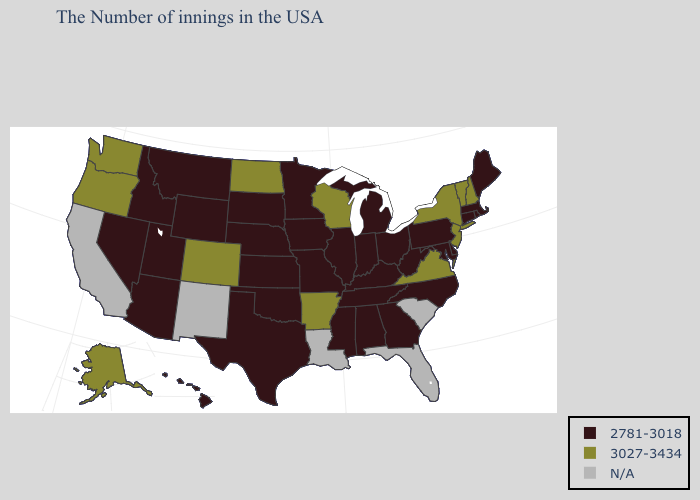What is the value of Hawaii?
Give a very brief answer. 2781-3018. Name the states that have a value in the range 3027-3434?
Write a very short answer. New Hampshire, Vermont, New York, New Jersey, Virginia, Wisconsin, Arkansas, North Dakota, Colorado, Washington, Oregon, Alaska. What is the highest value in the MidWest ?
Concise answer only. 3027-3434. Among the states that border Nebraska , does South Dakota have the highest value?
Short answer required. No. Name the states that have a value in the range N/A?
Quick response, please. South Carolina, Florida, Louisiana, New Mexico, California. Name the states that have a value in the range N/A?
Quick response, please. South Carolina, Florida, Louisiana, New Mexico, California. Name the states that have a value in the range 3027-3434?
Answer briefly. New Hampshire, Vermont, New York, New Jersey, Virginia, Wisconsin, Arkansas, North Dakota, Colorado, Washington, Oregon, Alaska. What is the value of Mississippi?
Concise answer only. 2781-3018. Among the states that border Washington , does Oregon have the highest value?
Be succinct. Yes. Name the states that have a value in the range 2781-3018?
Answer briefly. Maine, Massachusetts, Rhode Island, Connecticut, Delaware, Maryland, Pennsylvania, North Carolina, West Virginia, Ohio, Georgia, Michigan, Kentucky, Indiana, Alabama, Tennessee, Illinois, Mississippi, Missouri, Minnesota, Iowa, Kansas, Nebraska, Oklahoma, Texas, South Dakota, Wyoming, Utah, Montana, Arizona, Idaho, Nevada, Hawaii. Name the states that have a value in the range 3027-3434?
Answer briefly. New Hampshire, Vermont, New York, New Jersey, Virginia, Wisconsin, Arkansas, North Dakota, Colorado, Washington, Oregon, Alaska. Among the states that border Virginia , which have the highest value?
Keep it brief. Maryland, North Carolina, West Virginia, Kentucky, Tennessee. Name the states that have a value in the range N/A?
Be succinct. South Carolina, Florida, Louisiana, New Mexico, California. Among the states that border Missouri , does Arkansas have the highest value?
Keep it brief. Yes. 